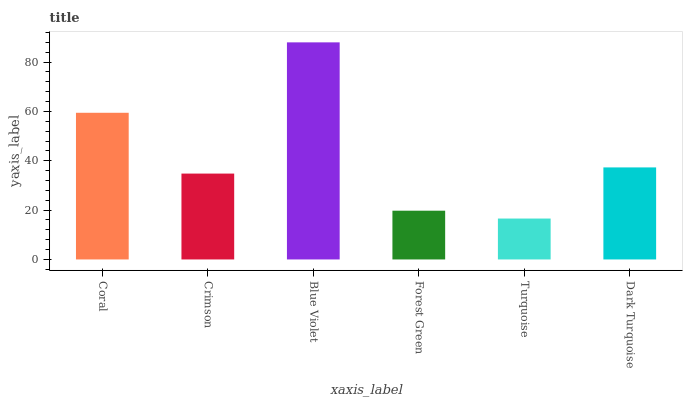Is Turquoise the minimum?
Answer yes or no. Yes. Is Blue Violet the maximum?
Answer yes or no. Yes. Is Crimson the minimum?
Answer yes or no. No. Is Crimson the maximum?
Answer yes or no. No. Is Coral greater than Crimson?
Answer yes or no. Yes. Is Crimson less than Coral?
Answer yes or no. Yes. Is Crimson greater than Coral?
Answer yes or no. No. Is Coral less than Crimson?
Answer yes or no. No. Is Dark Turquoise the high median?
Answer yes or no. Yes. Is Crimson the low median?
Answer yes or no. Yes. Is Blue Violet the high median?
Answer yes or no. No. Is Blue Violet the low median?
Answer yes or no. No. 